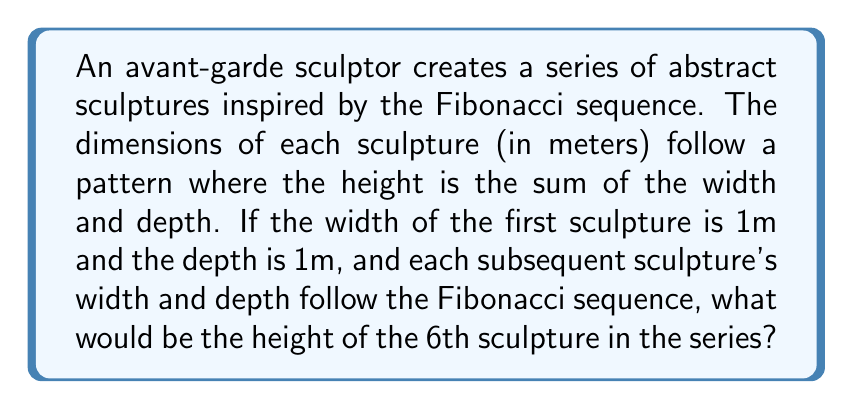Can you solve this math problem? Let's approach this step-by-step:

1. Recall the Fibonacci sequence: 1, 1, 2, 3, 5, 8, ...
   Each number is the sum of the two preceding ones.

2. Let's list the dimensions for each sculpture:

   Sculpture 1: Width = 1m, Depth = 1m, Height = 1 + 1 = 2m
   Sculpture 2: Width = 1m, Depth = 1m, Height = 1 + 1 = 2m
   Sculpture 3: Width = 2m, Depth = 2m, Height = 2 + 2 = 4m
   Sculpture 4: Width = 3m, Depth = 3m, Height = 3 + 3 = 6m
   Sculpture 5: Width = 5m, Depth = 5m, Height = 5 + 5 = 10m
   Sculpture 6: Width = 8m, Depth = 8m, Height = 8 + 8 = 16m

3. We can express this mathematically:
   Let $F_n$ be the nth Fibonacci number.
   For the 6th sculpture:
   Width = Depth = $F_7 = 8$
   Height = Width + Depth = $F_7 + F_7 = 8 + 8 = 16$

Therefore, the height of the 6th sculpture is 16 meters.
Answer: 16m 